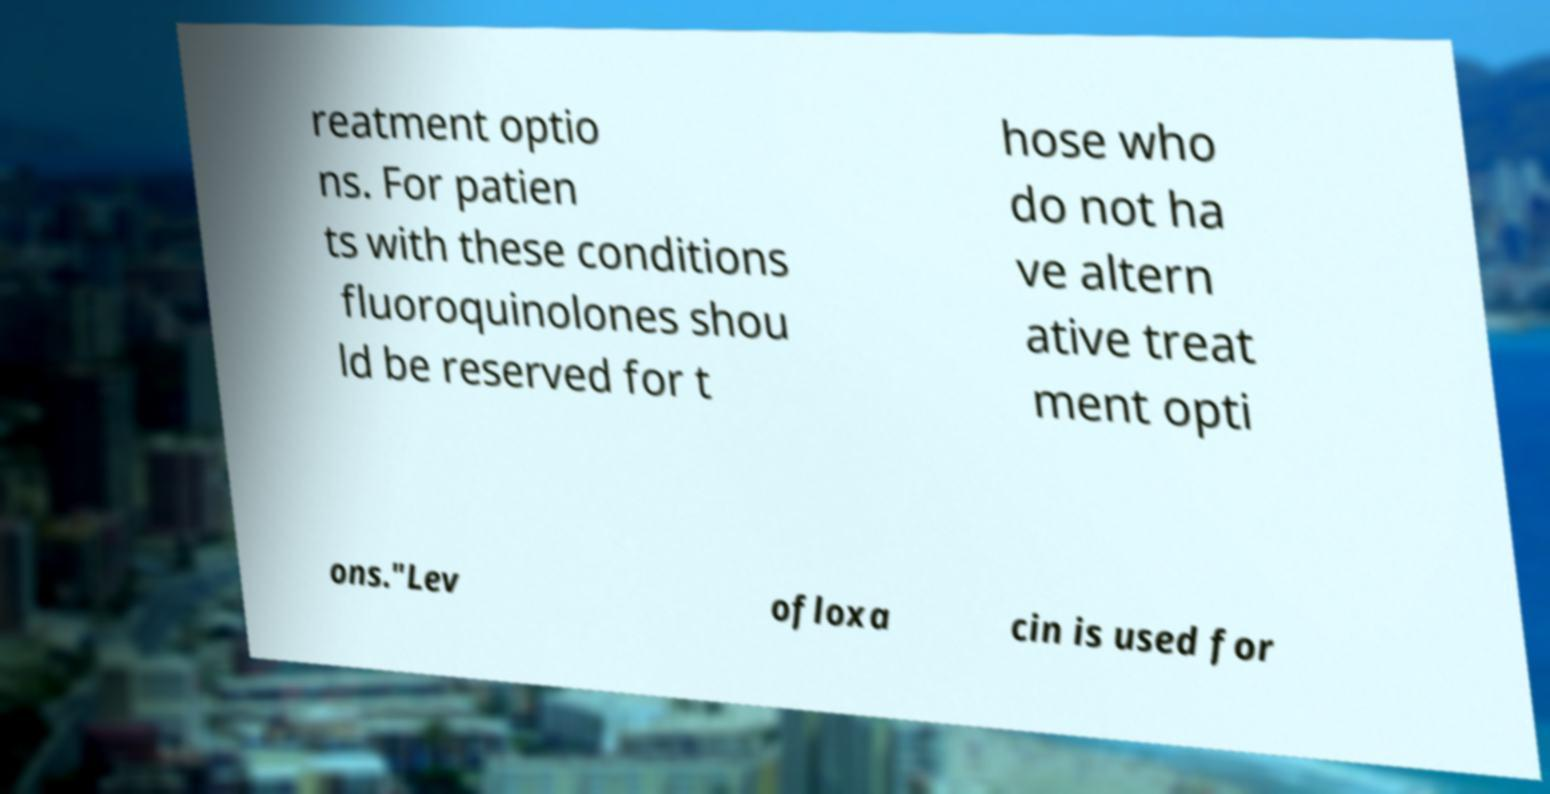Could you assist in decoding the text presented in this image and type it out clearly? reatment optio ns. For patien ts with these conditions fluoroquinolones shou ld be reserved for t hose who do not ha ve altern ative treat ment opti ons."Lev ofloxa cin is used for 